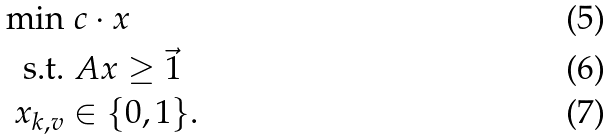Convert formula to latex. <formula><loc_0><loc_0><loc_500><loc_500>\min & \ c \cdot x \\ \text {s.t.} & \ A x \geq \vec { 1 } \\ \ x _ { k , v } & \in \{ 0 , 1 \} .</formula> 